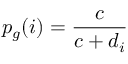<formula> <loc_0><loc_0><loc_500><loc_500>p _ { g } ( i ) = \frac { c } { c + d _ { i } }</formula> 